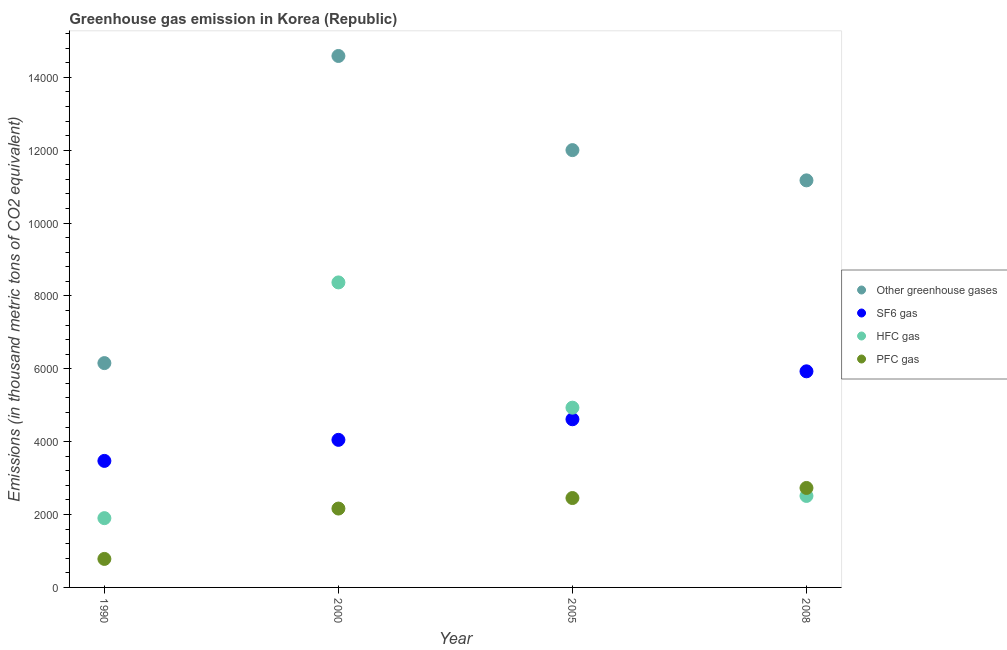Is the number of dotlines equal to the number of legend labels?
Give a very brief answer. Yes. What is the emission of hfc gas in 2000?
Your answer should be very brief. 8371.9. Across all years, what is the maximum emission of hfc gas?
Provide a succinct answer. 8371.9. Across all years, what is the minimum emission of pfc gas?
Offer a very short reply. 782.6. In which year was the emission of sf6 gas minimum?
Ensure brevity in your answer.  1990. What is the total emission of pfc gas in the graph?
Make the answer very short. 8131.3. What is the difference between the emission of sf6 gas in 2000 and that in 2005?
Offer a very short reply. -565.2. What is the difference between the emission of sf6 gas in 1990 and the emission of greenhouse gases in 2000?
Your answer should be compact. -1.11e+04. What is the average emission of sf6 gas per year?
Offer a very short reply. 4517.67. In the year 2008, what is the difference between the emission of sf6 gas and emission of pfc gas?
Your response must be concise. 3201.5. In how many years, is the emission of pfc gas greater than 4400 thousand metric tons?
Provide a short and direct response. 0. What is the ratio of the emission of greenhouse gases in 2005 to that in 2008?
Offer a very short reply. 1.07. Is the emission of sf6 gas in 1990 less than that in 2000?
Your answer should be compact. Yes. Is the difference between the emission of pfc gas in 2000 and 2008 greater than the difference between the emission of greenhouse gases in 2000 and 2008?
Keep it short and to the point. No. What is the difference between the highest and the second highest emission of pfc gas?
Ensure brevity in your answer.  276.4. What is the difference between the highest and the lowest emission of sf6 gas?
Offer a very short reply. 2458.7. In how many years, is the emission of hfc gas greater than the average emission of hfc gas taken over all years?
Your answer should be compact. 2. Is it the case that in every year, the sum of the emission of greenhouse gases and emission of sf6 gas is greater than the emission of hfc gas?
Your answer should be very brief. Yes. Is the emission of greenhouse gases strictly greater than the emission of sf6 gas over the years?
Offer a terse response. Yes. Is the emission of pfc gas strictly less than the emission of hfc gas over the years?
Your response must be concise. No. How many dotlines are there?
Ensure brevity in your answer.  4. How many years are there in the graph?
Your answer should be very brief. 4. What is the difference between two consecutive major ticks on the Y-axis?
Provide a short and direct response. 2000. Where does the legend appear in the graph?
Offer a very short reply. Center right. What is the title of the graph?
Offer a terse response. Greenhouse gas emission in Korea (Republic). Does "Permission" appear as one of the legend labels in the graph?
Offer a very short reply. No. What is the label or title of the X-axis?
Keep it short and to the point. Year. What is the label or title of the Y-axis?
Give a very brief answer. Emissions (in thousand metric tons of CO2 equivalent). What is the Emissions (in thousand metric tons of CO2 equivalent) in Other greenhouse gases in 1990?
Keep it short and to the point. 6157.2. What is the Emissions (in thousand metric tons of CO2 equivalent) of SF6 gas in 1990?
Provide a short and direct response. 3472.9. What is the Emissions (in thousand metric tons of CO2 equivalent) in HFC gas in 1990?
Keep it short and to the point. 1901.7. What is the Emissions (in thousand metric tons of CO2 equivalent) of PFC gas in 1990?
Your response must be concise. 782.6. What is the Emissions (in thousand metric tons of CO2 equivalent) in Other greenhouse gases in 2000?
Your response must be concise. 1.46e+04. What is the Emissions (in thousand metric tons of CO2 equivalent) in SF6 gas in 2000?
Your response must be concise. 4050.5. What is the Emissions (in thousand metric tons of CO2 equivalent) of HFC gas in 2000?
Give a very brief answer. 8371.9. What is the Emissions (in thousand metric tons of CO2 equivalent) of PFC gas in 2000?
Keep it short and to the point. 2164.9. What is the Emissions (in thousand metric tons of CO2 equivalent) of Other greenhouse gases in 2005?
Your answer should be compact. 1.20e+04. What is the Emissions (in thousand metric tons of CO2 equivalent) in SF6 gas in 2005?
Give a very brief answer. 4615.7. What is the Emissions (in thousand metric tons of CO2 equivalent) of HFC gas in 2005?
Your response must be concise. 4933.9. What is the Emissions (in thousand metric tons of CO2 equivalent) of PFC gas in 2005?
Offer a very short reply. 2453.7. What is the Emissions (in thousand metric tons of CO2 equivalent) in Other greenhouse gases in 2008?
Provide a succinct answer. 1.12e+04. What is the Emissions (in thousand metric tons of CO2 equivalent) of SF6 gas in 2008?
Offer a very short reply. 5931.6. What is the Emissions (in thousand metric tons of CO2 equivalent) of HFC gas in 2008?
Make the answer very short. 2511.2. What is the Emissions (in thousand metric tons of CO2 equivalent) of PFC gas in 2008?
Give a very brief answer. 2730.1. Across all years, what is the maximum Emissions (in thousand metric tons of CO2 equivalent) in Other greenhouse gases?
Your response must be concise. 1.46e+04. Across all years, what is the maximum Emissions (in thousand metric tons of CO2 equivalent) in SF6 gas?
Provide a short and direct response. 5931.6. Across all years, what is the maximum Emissions (in thousand metric tons of CO2 equivalent) in HFC gas?
Your answer should be compact. 8371.9. Across all years, what is the maximum Emissions (in thousand metric tons of CO2 equivalent) in PFC gas?
Your response must be concise. 2730.1. Across all years, what is the minimum Emissions (in thousand metric tons of CO2 equivalent) in Other greenhouse gases?
Give a very brief answer. 6157.2. Across all years, what is the minimum Emissions (in thousand metric tons of CO2 equivalent) in SF6 gas?
Provide a succinct answer. 3472.9. Across all years, what is the minimum Emissions (in thousand metric tons of CO2 equivalent) in HFC gas?
Your answer should be very brief. 1901.7. Across all years, what is the minimum Emissions (in thousand metric tons of CO2 equivalent) of PFC gas?
Your response must be concise. 782.6. What is the total Emissions (in thousand metric tons of CO2 equivalent) of Other greenhouse gases in the graph?
Give a very brief answer. 4.39e+04. What is the total Emissions (in thousand metric tons of CO2 equivalent) of SF6 gas in the graph?
Your response must be concise. 1.81e+04. What is the total Emissions (in thousand metric tons of CO2 equivalent) in HFC gas in the graph?
Give a very brief answer. 1.77e+04. What is the total Emissions (in thousand metric tons of CO2 equivalent) of PFC gas in the graph?
Your response must be concise. 8131.3. What is the difference between the Emissions (in thousand metric tons of CO2 equivalent) in Other greenhouse gases in 1990 and that in 2000?
Ensure brevity in your answer.  -8430.1. What is the difference between the Emissions (in thousand metric tons of CO2 equivalent) in SF6 gas in 1990 and that in 2000?
Provide a succinct answer. -577.6. What is the difference between the Emissions (in thousand metric tons of CO2 equivalent) in HFC gas in 1990 and that in 2000?
Your answer should be compact. -6470.2. What is the difference between the Emissions (in thousand metric tons of CO2 equivalent) in PFC gas in 1990 and that in 2000?
Your response must be concise. -1382.3. What is the difference between the Emissions (in thousand metric tons of CO2 equivalent) in Other greenhouse gases in 1990 and that in 2005?
Keep it short and to the point. -5846.1. What is the difference between the Emissions (in thousand metric tons of CO2 equivalent) of SF6 gas in 1990 and that in 2005?
Make the answer very short. -1142.8. What is the difference between the Emissions (in thousand metric tons of CO2 equivalent) in HFC gas in 1990 and that in 2005?
Offer a very short reply. -3032.2. What is the difference between the Emissions (in thousand metric tons of CO2 equivalent) of PFC gas in 1990 and that in 2005?
Your answer should be very brief. -1671.1. What is the difference between the Emissions (in thousand metric tons of CO2 equivalent) of Other greenhouse gases in 1990 and that in 2008?
Your answer should be compact. -5015.7. What is the difference between the Emissions (in thousand metric tons of CO2 equivalent) in SF6 gas in 1990 and that in 2008?
Make the answer very short. -2458.7. What is the difference between the Emissions (in thousand metric tons of CO2 equivalent) in HFC gas in 1990 and that in 2008?
Your response must be concise. -609.5. What is the difference between the Emissions (in thousand metric tons of CO2 equivalent) in PFC gas in 1990 and that in 2008?
Provide a short and direct response. -1947.5. What is the difference between the Emissions (in thousand metric tons of CO2 equivalent) of Other greenhouse gases in 2000 and that in 2005?
Offer a very short reply. 2584. What is the difference between the Emissions (in thousand metric tons of CO2 equivalent) of SF6 gas in 2000 and that in 2005?
Keep it short and to the point. -565.2. What is the difference between the Emissions (in thousand metric tons of CO2 equivalent) in HFC gas in 2000 and that in 2005?
Offer a very short reply. 3438. What is the difference between the Emissions (in thousand metric tons of CO2 equivalent) in PFC gas in 2000 and that in 2005?
Make the answer very short. -288.8. What is the difference between the Emissions (in thousand metric tons of CO2 equivalent) of Other greenhouse gases in 2000 and that in 2008?
Provide a short and direct response. 3414.4. What is the difference between the Emissions (in thousand metric tons of CO2 equivalent) of SF6 gas in 2000 and that in 2008?
Give a very brief answer. -1881.1. What is the difference between the Emissions (in thousand metric tons of CO2 equivalent) in HFC gas in 2000 and that in 2008?
Give a very brief answer. 5860.7. What is the difference between the Emissions (in thousand metric tons of CO2 equivalent) of PFC gas in 2000 and that in 2008?
Offer a terse response. -565.2. What is the difference between the Emissions (in thousand metric tons of CO2 equivalent) in Other greenhouse gases in 2005 and that in 2008?
Your response must be concise. 830.4. What is the difference between the Emissions (in thousand metric tons of CO2 equivalent) of SF6 gas in 2005 and that in 2008?
Your response must be concise. -1315.9. What is the difference between the Emissions (in thousand metric tons of CO2 equivalent) in HFC gas in 2005 and that in 2008?
Offer a terse response. 2422.7. What is the difference between the Emissions (in thousand metric tons of CO2 equivalent) in PFC gas in 2005 and that in 2008?
Give a very brief answer. -276.4. What is the difference between the Emissions (in thousand metric tons of CO2 equivalent) in Other greenhouse gases in 1990 and the Emissions (in thousand metric tons of CO2 equivalent) in SF6 gas in 2000?
Offer a very short reply. 2106.7. What is the difference between the Emissions (in thousand metric tons of CO2 equivalent) in Other greenhouse gases in 1990 and the Emissions (in thousand metric tons of CO2 equivalent) in HFC gas in 2000?
Ensure brevity in your answer.  -2214.7. What is the difference between the Emissions (in thousand metric tons of CO2 equivalent) of Other greenhouse gases in 1990 and the Emissions (in thousand metric tons of CO2 equivalent) of PFC gas in 2000?
Your answer should be compact. 3992.3. What is the difference between the Emissions (in thousand metric tons of CO2 equivalent) in SF6 gas in 1990 and the Emissions (in thousand metric tons of CO2 equivalent) in HFC gas in 2000?
Ensure brevity in your answer.  -4899. What is the difference between the Emissions (in thousand metric tons of CO2 equivalent) of SF6 gas in 1990 and the Emissions (in thousand metric tons of CO2 equivalent) of PFC gas in 2000?
Your answer should be very brief. 1308. What is the difference between the Emissions (in thousand metric tons of CO2 equivalent) in HFC gas in 1990 and the Emissions (in thousand metric tons of CO2 equivalent) in PFC gas in 2000?
Your answer should be compact. -263.2. What is the difference between the Emissions (in thousand metric tons of CO2 equivalent) in Other greenhouse gases in 1990 and the Emissions (in thousand metric tons of CO2 equivalent) in SF6 gas in 2005?
Offer a terse response. 1541.5. What is the difference between the Emissions (in thousand metric tons of CO2 equivalent) of Other greenhouse gases in 1990 and the Emissions (in thousand metric tons of CO2 equivalent) of HFC gas in 2005?
Your answer should be compact. 1223.3. What is the difference between the Emissions (in thousand metric tons of CO2 equivalent) of Other greenhouse gases in 1990 and the Emissions (in thousand metric tons of CO2 equivalent) of PFC gas in 2005?
Give a very brief answer. 3703.5. What is the difference between the Emissions (in thousand metric tons of CO2 equivalent) in SF6 gas in 1990 and the Emissions (in thousand metric tons of CO2 equivalent) in HFC gas in 2005?
Provide a succinct answer. -1461. What is the difference between the Emissions (in thousand metric tons of CO2 equivalent) of SF6 gas in 1990 and the Emissions (in thousand metric tons of CO2 equivalent) of PFC gas in 2005?
Offer a very short reply. 1019.2. What is the difference between the Emissions (in thousand metric tons of CO2 equivalent) in HFC gas in 1990 and the Emissions (in thousand metric tons of CO2 equivalent) in PFC gas in 2005?
Keep it short and to the point. -552. What is the difference between the Emissions (in thousand metric tons of CO2 equivalent) of Other greenhouse gases in 1990 and the Emissions (in thousand metric tons of CO2 equivalent) of SF6 gas in 2008?
Keep it short and to the point. 225.6. What is the difference between the Emissions (in thousand metric tons of CO2 equivalent) in Other greenhouse gases in 1990 and the Emissions (in thousand metric tons of CO2 equivalent) in HFC gas in 2008?
Offer a very short reply. 3646. What is the difference between the Emissions (in thousand metric tons of CO2 equivalent) in Other greenhouse gases in 1990 and the Emissions (in thousand metric tons of CO2 equivalent) in PFC gas in 2008?
Provide a short and direct response. 3427.1. What is the difference between the Emissions (in thousand metric tons of CO2 equivalent) in SF6 gas in 1990 and the Emissions (in thousand metric tons of CO2 equivalent) in HFC gas in 2008?
Make the answer very short. 961.7. What is the difference between the Emissions (in thousand metric tons of CO2 equivalent) in SF6 gas in 1990 and the Emissions (in thousand metric tons of CO2 equivalent) in PFC gas in 2008?
Give a very brief answer. 742.8. What is the difference between the Emissions (in thousand metric tons of CO2 equivalent) of HFC gas in 1990 and the Emissions (in thousand metric tons of CO2 equivalent) of PFC gas in 2008?
Offer a very short reply. -828.4. What is the difference between the Emissions (in thousand metric tons of CO2 equivalent) in Other greenhouse gases in 2000 and the Emissions (in thousand metric tons of CO2 equivalent) in SF6 gas in 2005?
Your answer should be compact. 9971.6. What is the difference between the Emissions (in thousand metric tons of CO2 equivalent) in Other greenhouse gases in 2000 and the Emissions (in thousand metric tons of CO2 equivalent) in HFC gas in 2005?
Provide a short and direct response. 9653.4. What is the difference between the Emissions (in thousand metric tons of CO2 equivalent) in Other greenhouse gases in 2000 and the Emissions (in thousand metric tons of CO2 equivalent) in PFC gas in 2005?
Provide a succinct answer. 1.21e+04. What is the difference between the Emissions (in thousand metric tons of CO2 equivalent) of SF6 gas in 2000 and the Emissions (in thousand metric tons of CO2 equivalent) of HFC gas in 2005?
Offer a very short reply. -883.4. What is the difference between the Emissions (in thousand metric tons of CO2 equivalent) of SF6 gas in 2000 and the Emissions (in thousand metric tons of CO2 equivalent) of PFC gas in 2005?
Make the answer very short. 1596.8. What is the difference between the Emissions (in thousand metric tons of CO2 equivalent) in HFC gas in 2000 and the Emissions (in thousand metric tons of CO2 equivalent) in PFC gas in 2005?
Provide a short and direct response. 5918.2. What is the difference between the Emissions (in thousand metric tons of CO2 equivalent) in Other greenhouse gases in 2000 and the Emissions (in thousand metric tons of CO2 equivalent) in SF6 gas in 2008?
Your answer should be compact. 8655.7. What is the difference between the Emissions (in thousand metric tons of CO2 equivalent) in Other greenhouse gases in 2000 and the Emissions (in thousand metric tons of CO2 equivalent) in HFC gas in 2008?
Offer a very short reply. 1.21e+04. What is the difference between the Emissions (in thousand metric tons of CO2 equivalent) of Other greenhouse gases in 2000 and the Emissions (in thousand metric tons of CO2 equivalent) of PFC gas in 2008?
Give a very brief answer. 1.19e+04. What is the difference between the Emissions (in thousand metric tons of CO2 equivalent) of SF6 gas in 2000 and the Emissions (in thousand metric tons of CO2 equivalent) of HFC gas in 2008?
Your response must be concise. 1539.3. What is the difference between the Emissions (in thousand metric tons of CO2 equivalent) of SF6 gas in 2000 and the Emissions (in thousand metric tons of CO2 equivalent) of PFC gas in 2008?
Your answer should be very brief. 1320.4. What is the difference between the Emissions (in thousand metric tons of CO2 equivalent) in HFC gas in 2000 and the Emissions (in thousand metric tons of CO2 equivalent) in PFC gas in 2008?
Make the answer very short. 5641.8. What is the difference between the Emissions (in thousand metric tons of CO2 equivalent) of Other greenhouse gases in 2005 and the Emissions (in thousand metric tons of CO2 equivalent) of SF6 gas in 2008?
Give a very brief answer. 6071.7. What is the difference between the Emissions (in thousand metric tons of CO2 equivalent) of Other greenhouse gases in 2005 and the Emissions (in thousand metric tons of CO2 equivalent) of HFC gas in 2008?
Your answer should be compact. 9492.1. What is the difference between the Emissions (in thousand metric tons of CO2 equivalent) in Other greenhouse gases in 2005 and the Emissions (in thousand metric tons of CO2 equivalent) in PFC gas in 2008?
Your response must be concise. 9273.2. What is the difference between the Emissions (in thousand metric tons of CO2 equivalent) of SF6 gas in 2005 and the Emissions (in thousand metric tons of CO2 equivalent) of HFC gas in 2008?
Provide a succinct answer. 2104.5. What is the difference between the Emissions (in thousand metric tons of CO2 equivalent) in SF6 gas in 2005 and the Emissions (in thousand metric tons of CO2 equivalent) in PFC gas in 2008?
Offer a very short reply. 1885.6. What is the difference between the Emissions (in thousand metric tons of CO2 equivalent) of HFC gas in 2005 and the Emissions (in thousand metric tons of CO2 equivalent) of PFC gas in 2008?
Provide a short and direct response. 2203.8. What is the average Emissions (in thousand metric tons of CO2 equivalent) of Other greenhouse gases per year?
Provide a short and direct response. 1.10e+04. What is the average Emissions (in thousand metric tons of CO2 equivalent) in SF6 gas per year?
Offer a terse response. 4517.68. What is the average Emissions (in thousand metric tons of CO2 equivalent) in HFC gas per year?
Your response must be concise. 4429.68. What is the average Emissions (in thousand metric tons of CO2 equivalent) in PFC gas per year?
Provide a succinct answer. 2032.83. In the year 1990, what is the difference between the Emissions (in thousand metric tons of CO2 equivalent) of Other greenhouse gases and Emissions (in thousand metric tons of CO2 equivalent) of SF6 gas?
Provide a succinct answer. 2684.3. In the year 1990, what is the difference between the Emissions (in thousand metric tons of CO2 equivalent) of Other greenhouse gases and Emissions (in thousand metric tons of CO2 equivalent) of HFC gas?
Keep it short and to the point. 4255.5. In the year 1990, what is the difference between the Emissions (in thousand metric tons of CO2 equivalent) of Other greenhouse gases and Emissions (in thousand metric tons of CO2 equivalent) of PFC gas?
Provide a succinct answer. 5374.6. In the year 1990, what is the difference between the Emissions (in thousand metric tons of CO2 equivalent) of SF6 gas and Emissions (in thousand metric tons of CO2 equivalent) of HFC gas?
Your answer should be very brief. 1571.2. In the year 1990, what is the difference between the Emissions (in thousand metric tons of CO2 equivalent) of SF6 gas and Emissions (in thousand metric tons of CO2 equivalent) of PFC gas?
Your answer should be very brief. 2690.3. In the year 1990, what is the difference between the Emissions (in thousand metric tons of CO2 equivalent) in HFC gas and Emissions (in thousand metric tons of CO2 equivalent) in PFC gas?
Provide a short and direct response. 1119.1. In the year 2000, what is the difference between the Emissions (in thousand metric tons of CO2 equivalent) in Other greenhouse gases and Emissions (in thousand metric tons of CO2 equivalent) in SF6 gas?
Keep it short and to the point. 1.05e+04. In the year 2000, what is the difference between the Emissions (in thousand metric tons of CO2 equivalent) in Other greenhouse gases and Emissions (in thousand metric tons of CO2 equivalent) in HFC gas?
Give a very brief answer. 6215.4. In the year 2000, what is the difference between the Emissions (in thousand metric tons of CO2 equivalent) of Other greenhouse gases and Emissions (in thousand metric tons of CO2 equivalent) of PFC gas?
Make the answer very short. 1.24e+04. In the year 2000, what is the difference between the Emissions (in thousand metric tons of CO2 equivalent) of SF6 gas and Emissions (in thousand metric tons of CO2 equivalent) of HFC gas?
Make the answer very short. -4321.4. In the year 2000, what is the difference between the Emissions (in thousand metric tons of CO2 equivalent) of SF6 gas and Emissions (in thousand metric tons of CO2 equivalent) of PFC gas?
Your answer should be very brief. 1885.6. In the year 2000, what is the difference between the Emissions (in thousand metric tons of CO2 equivalent) of HFC gas and Emissions (in thousand metric tons of CO2 equivalent) of PFC gas?
Provide a succinct answer. 6207. In the year 2005, what is the difference between the Emissions (in thousand metric tons of CO2 equivalent) of Other greenhouse gases and Emissions (in thousand metric tons of CO2 equivalent) of SF6 gas?
Provide a short and direct response. 7387.6. In the year 2005, what is the difference between the Emissions (in thousand metric tons of CO2 equivalent) of Other greenhouse gases and Emissions (in thousand metric tons of CO2 equivalent) of HFC gas?
Offer a very short reply. 7069.4. In the year 2005, what is the difference between the Emissions (in thousand metric tons of CO2 equivalent) in Other greenhouse gases and Emissions (in thousand metric tons of CO2 equivalent) in PFC gas?
Make the answer very short. 9549.6. In the year 2005, what is the difference between the Emissions (in thousand metric tons of CO2 equivalent) in SF6 gas and Emissions (in thousand metric tons of CO2 equivalent) in HFC gas?
Provide a short and direct response. -318.2. In the year 2005, what is the difference between the Emissions (in thousand metric tons of CO2 equivalent) of SF6 gas and Emissions (in thousand metric tons of CO2 equivalent) of PFC gas?
Your answer should be compact. 2162. In the year 2005, what is the difference between the Emissions (in thousand metric tons of CO2 equivalent) in HFC gas and Emissions (in thousand metric tons of CO2 equivalent) in PFC gas?
Your answer should be very brief. 2480.2. In the year 2008, what is the difference between the Emissions (in thousand metric tons of CO2 equivalent) of Other greenhouse gases and Emissions (in thousand metric tons of CO2 equivalent) of SF6 gas?
Your answer should be very brief. 5241.3. In the year 2008, what is the difference between the Emissions (in thousand metric tons of CO2 equivalent) of Other greenhouse gases and Emissions (in thousand metric tons of CO2 equivalent) of HFC gas?
Your response must be concise. 8661.7. In the year 2008, what is the difference between the Emissions (in thousand metric tons of CO2 equivalent) in Other greenhouse gases and Emissions (in thousand metric tons of CO2 equivalent) in PFC gas?
Offer a terse response. 8442.8. In the year 2008, what is the difference between the Emissions (in thousand metric tons of CO2 equivalent) of SF6 gas and Emissions (in thousand metric tons of CO2 equivalent) of HFC gas?
Make the answer very short. 3420.4. In the year 2008, what is the difference between the Emissions (in thousand metric tons of CO2 equivalent) in SF6 gas and Emissions (in thousand metric tons of CO2 equivalent) in PFC gas?
Offer a very short reply. 3201.5. In the year 2008, what is the difference between the Emissions (in thousand metric tons of CO2 equivalent) in HFC gas and Emissions (in thousand metric tons of CO2 equivalent) in PFC gas?
Keep it short and to the point. -218.9. What is the ratio of the Emissions (in thousand metric tons of CO2 equivalent) in Other greenhouse gases in 1990 to that in 2000?
Provide a short and direct response. 0.42. What is the ratio of the Emissions (in thousand metric tons of CO2 equivalent) in SF6 gas in 1990 to that in 2000?
Offer a very short reply. 0.86. What is the ratio of the Emissions (in thousand metric tons of CO2 equivalent) of HFC gas in 1990 to that in 2000?
Give a very brief answer. 0.23. What is the ratio of the Emissions (in thousand metric tons of CO2 equivalent) in PFC gas in 1990 to that in 2000?
Provide a succinct answer. 0.36. What is the ratio of the Emissions (in thousand metric tons of CO2 equivalent) in Other greenhouse gases in 1990 to that in 2005?
Provide a short and direct response. 0.51. What is the ratio of the Emissions (in thousand metric tons of CO2 equivalent) in SF6 gas in 1990 to that in 2005?
Make the answer very short. 0.75. What is the ratio of the Emissions (in thousand metric tons of CO2 equivalent) in HFC gas in 1990 to that in 2005?
Offer a very short reply. 0.39. What is the ratio of the Emissions (in thousand metric tons of CO2 equivalent) in PFC gas in 1990 to that in 2005?
Ensure brevity in your answer.  0.32. What is the ratio of the Emissions (in thousand metric tons of CO2 equivalent) of Other greenhouse gases in 1990 to that in 2008?
Keep it short and to the point. 0.55. What is the ratio of the Emissions (in thousand metric tons of CO2 equivalent) of SF6 gas in 1990 to that in 2008?
Your response must be concise. 0.59. What is the ratio of the Emissions (in thousand metric tons of CO2 equivalent) of HFC gas in 1990 to that in 2008?
Your answer should be very brief. 0.76. What is the ratio of the Emissions (in thousand metric tons of CO2 equivalent) in PFC gas in 1990 to that in 2008?
Your answer should be compact. 0.29. What is the ratio of the Emissions (in thousand metric tons of CO2 equivalent) in Other greenhouse gases in 2000 to that in 2005?
Your answer should be very brief. 1.22. What is the ratio of the Emissions (in thousand metric tons of CO2 equivalent) of SF6 gas in 2000 to that in 2005?
Offer a terse response. 0.88. What is the ratio of the Emissions (in thousand metric tons of CO2 equivalent) in HFC gas in 2000 to that in 2005?
Your response must be concise. 1.7. What is the ratio of the Emissions (in thousand metric tons of CO2 equivalent) in PFC gas in 2000 to that in 2005?
Your answer should be very brief. 0.88. What is the ratio of the Emissions (in thousand metric tons of CO2 equivalent) of Other greenhouse gases in 2000 to that in 2008?
Your answer should be compact. 1.31. What is the ratio of the Emissions (in thousand metric tons of CO2 equivalent) in SF6 gas in 2000 to that in 2008?
Provide a short and direct response. 0.68. What is the ratio of the Emissions (in thousand metric tons of CO2 equivalent) in HFC gas in 2000 to that in 2008?
Your answer should be compact. 3.33. What is the ratio of the Emissions (in thousand metric tons of CO2 equivalent) of PFC gas in 2000 to that in 2008?
Keep it short and to the point. 0.79. What is the ratio of the Emissions (in thousand metric tons of CO2 equivalent) in Other greenhouse gases in 2005 to that in 2008?
Provide a short and direct response. 1.07. What is the ratio of the Emissions (in thousand metric tons of CO2 equivalent) of SF6 gas in 2005 to that in 2008?
Your response must be concise. 0.78. What is the ratio of the Emissions (in thousand metric tons of CO2 equivalent) of HFC gas in 2005 to that in 2008?
Provide a succinct answer. 1.96. What is the ratio of the Emissions (in thousand metric tons of CO2 equivalent) in PFC gas in 2005 to that in 2008?
Your answer should be very brief. 0.9. What is the difference between the highest and the second highest Emissions (in thousand metric tons of CO2 equivalent) in Other greenhouse gases?
Provide a short and direct response. 2584. What is the difference between the highest and the second highest Emissions (in thousand metric tons of CO2 equivalent) of SF6 gas?
Your answer should be compact. 1315.9. What is the difference between the highest and the second highest Emissions (in thousand metric tons of CO2 equivalent) in HFC gas?
Make the answer very short. 3438. What is the difference between the highest and the second highest Emissions (in thousand metric tons of CO2 equivalent) in PFC gas?
Provide a succinct answer. 276.4. What is the difference between the highest and the lowest Emissions (in thousand metric tons of CO2 equivalent) of Other greenhouse gases?
Offer a very short reply. 8430.1. What is the difference between the highest and the lowest Emissions (in thousand metric tons of CO2 equivalent) in SF6 gas?
Provide a succinct answer. 2458.7. What is the difference between the highest and the lowest Emissions (in thousand metric tons of CO2 equivalent) in HFC gas?
Give a very brief answer. 6470.2. What is the difference between the highest and the lowest Emissions (in thousand metric tons of CO2 equivalent) in PFC gas?
Provide a succinct answer. 1947.5. 